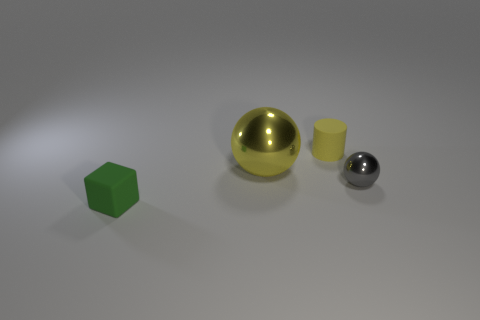Add 4 yellow metal spheres. How many objects exist? 8 Subtract all small cylinders. Subtract all yellow matte cylinders. How many objects are left? 2 Add 3 small balls. How many small balls are left? 4 Add 1 yellow cylinders. How many yellow cylinders exist? 2 Subtract 0 gray cylinders. How many objects are left? 4 